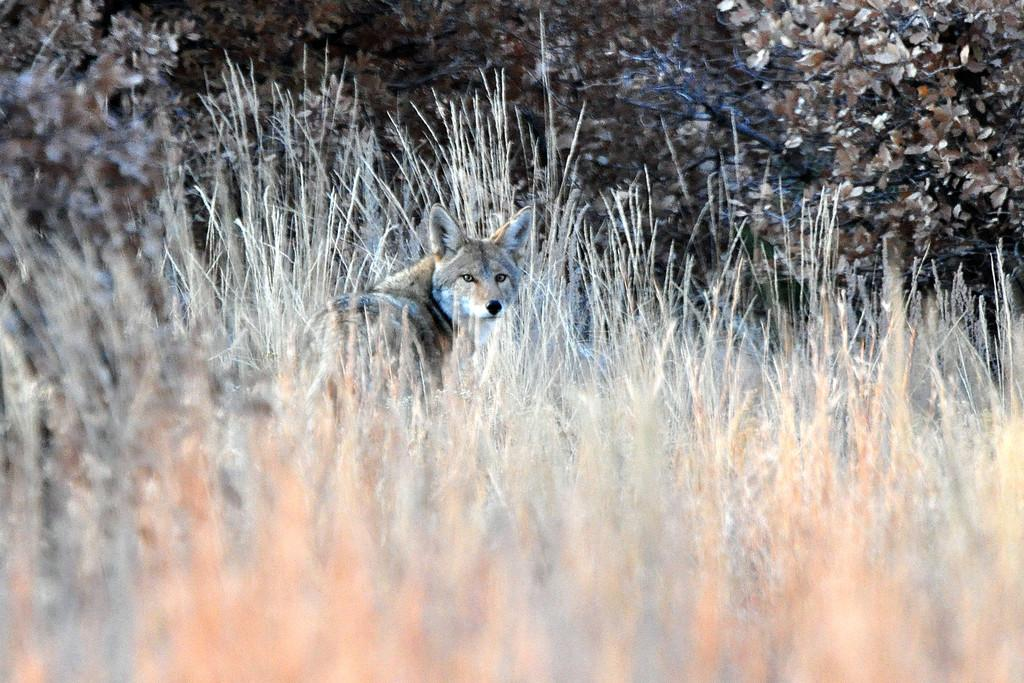What type of animal can be seen in the image? There is an animal in the image, but its specific type cannot be determined from the provided facts. How can you describe the coloring of the animal? The animal has white and brown coloring. What is the animal's location in the image? The animal is in-between dried grass. What can be seen in the background of the image? There are trees visible in the image. What type of blade is being used by the dinosaurs in the image? There are no dinosaurs present in the image, and therefore no blades are being used by them. 